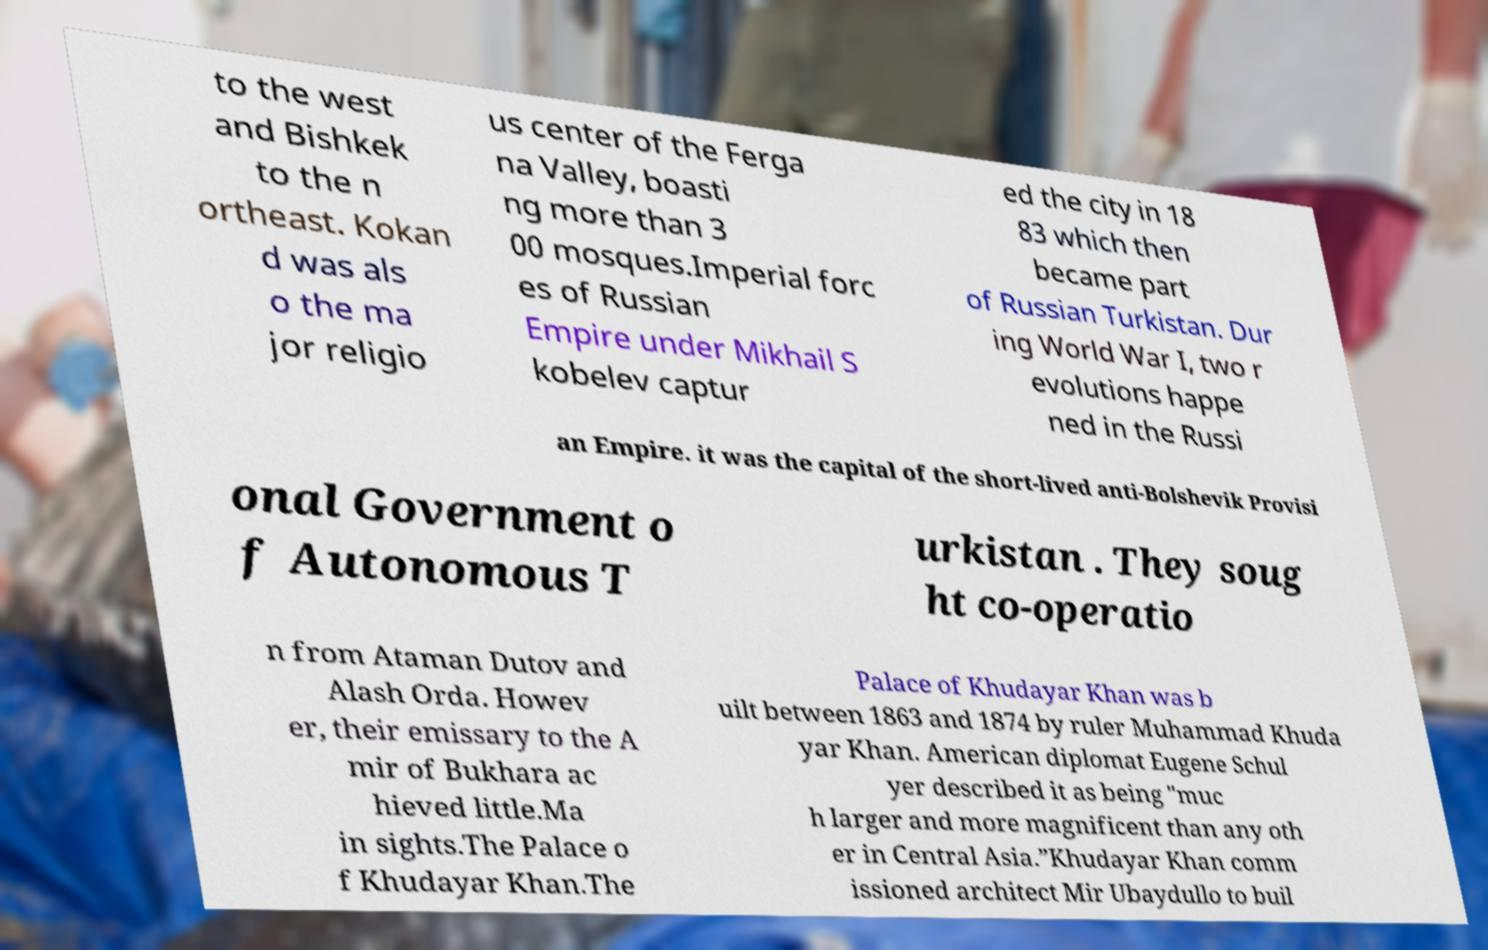For documentation purposes, I need the text within this image transcribed. Could you provide that? to the west and Bishkek to the n ortheast. Kokan d was als o the ma jor religio us center of the Ferga na Valley, boasti ng more than 3 00 mosques.Imperial forc es of Russian Empire under Mikhail S kobelev captur ed the city in 18 83 which then became part of Russian Turkistan. Dur ing World War I, two r evolutions happe ned in the Russi an Empire. it was the capital of the short-lived anti-Bolshevik Provisi onal Government o f Autonomous T urkistan . They soug ht co-operatio n from Ataman Dutov and Alash Orda. Howev er, their emissary to the A mir of Bukhara ac hieved little.Ma in sights.The Palace o f Khudayar Khan.The Palace of Khudayar Khan was b uilt between 1863 and 1874 by ruler Muhammad Khuda yar Khan. American diplomat Eugene Schul yer described it as being "muc h larger and more magnificent than any oth er in Central Asia.”Khudayar Khan comm issioned architect Mir Ubaydullo to buil 